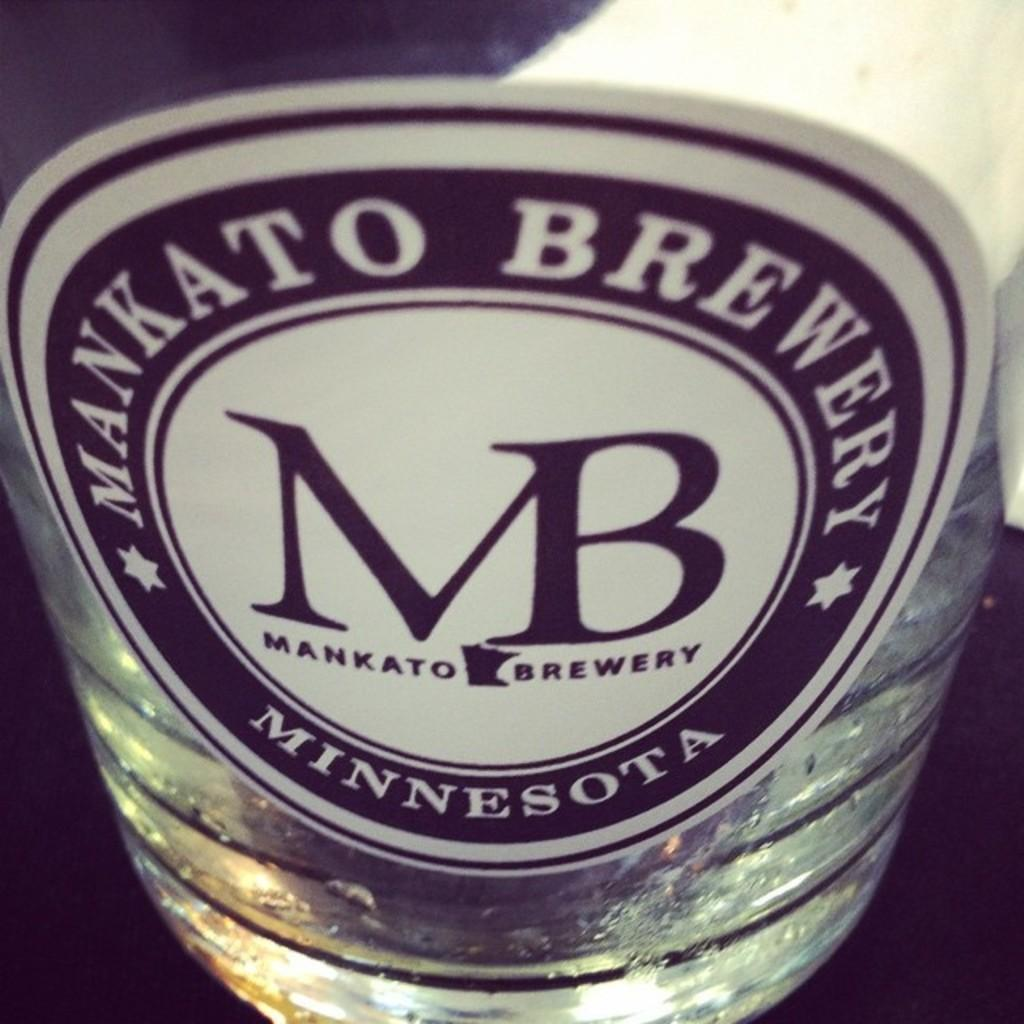<image>
Provide a brief description of the given image. a clear glass that has a label that say 'mankato brewery minnesota' on it 